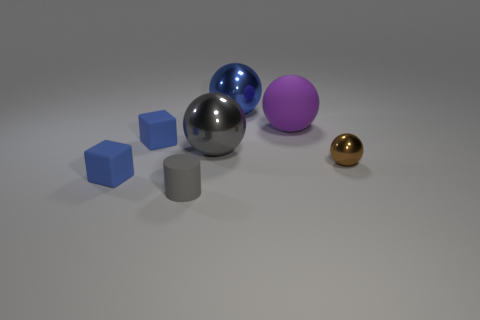Subtract all large gray shiny spheres. How many spheres are left? 3 Add 1 big purple matte things. How many objects exist? 8 Subtract all purple spheres. How many spheres are left? 3 Subtract all cylinders. How many objects are left? 6 Subtract 2 cubes. How many cubes are left? 0 Add 5 brown things. How many brown things exist? 6 Subtract 0 cyan blocks. How many objects are left? 7 Subtract all yellow balls. Subtract all brown cylinders. How many balls are left? 4 Subtract all cyan blocks. How many blue balls are left? 1 Subtract all tiny gray matte cylinders. Subtract all big metallic objects. How many objects are left? 4 